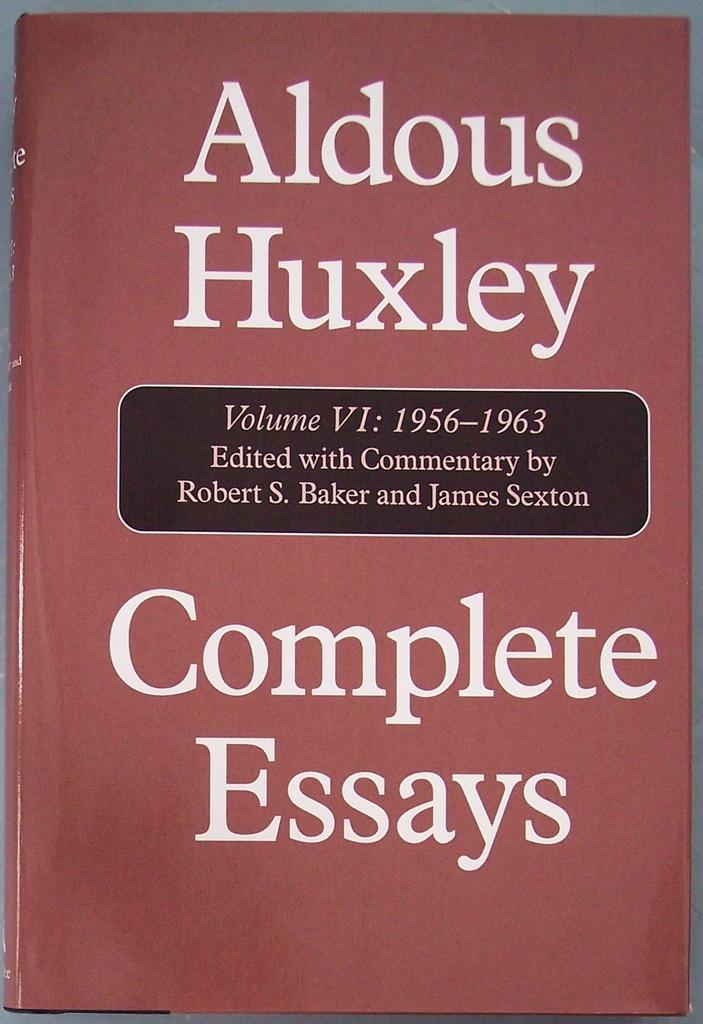Who provides commentary in this work?
Ensure brevity in your answer.  Robert s. baker and james sexton. 